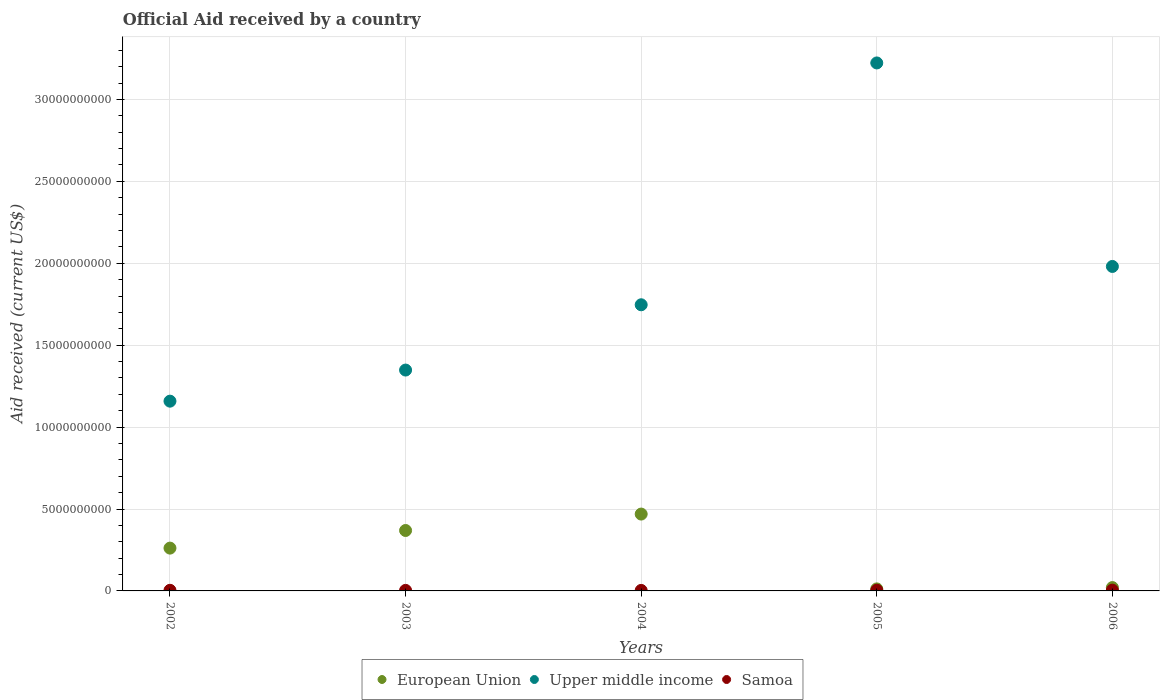How many different coloured dotlines are there?
Your answer should be very brief. 3. What is the net official aid received in Samoa in 2004?
Offer a very short reply. 3.09e+07. Across all years, what is the maximum net official aid received in Upper middle income?
Your response must be concise. 3.22e+1. Across all years, what is the minimum net official aid received in European Union?
Make the answer very short. 1.23e+08. In which year was the net official aid received in European Union maximum?
Ensure brevity in your answer.  2004. In which year was the net official aid received in Samoa minimum?
Your answer should be compact. 2004. What is the total net official aid received in Samoa in the graph?
Ensure brevity in your answer.  1.92e+08. What is the difference between the net official aid received in Samoa in 2004 and that in 2006?
Keep it short and to the point. -1.61e+07. What is the difference between the net official aid received in European Union in 2004 and the net official aid received in Samoa in 2003?
Provide a short and direct response. 4.66e+09. What is the average net official aid received in Samoa per year?
Your answer should be compact. 3.85e+07. In the year 2003, what is the difference between the net official aid received in Samoa and net official aid received in Upper middle income?
Make the answer very short. -1.34e+1. In how many years, is the net official aid received in Samoa greater than 4000000000 US$?
Provide a short and direct response. 0. What is the ratio of the net official aid received in European Union in 2002 to that in 2006?
Keep it short and to the point. 12.82. What is the difference between the highest and the second highest net official aid received in Samoa?
Offer a very short reply. 3.52e+06. What is the difference between the highest and the lowest net official aid received in Upper middle income?
Keep it short and to the point. 2.06e+1. Is the sum of the net official aid received in Upper middle income in 2002 and 2004 greater than the maximum net official aid received in Samoa across all years?
Provide a short and direct response. Yes. How many dotlines are there?
Your answer should be compact. 3. How many years are there in the graph?
Give a very brief answer. 5. What is the difference between two consecutive major ticks on the Y-axis?
Make the answer very short. 5.00e+09. Does the graph contain any zero values?
Keep it short and to the point. No. Does the graph contain grids?
Make the answer very short. Yes. Where does the legend appear in the graph?
Your response must be concise. Bottom center. What is the title of the graph?
Your response must be concise. Official Aid received by a country. What is the label or title of the X-axis?
Your answer should be very brief. Years. What is the label or title of the Y-axis?
Ensure brevity in your answer.  Aid received (current US$). What is the Aid received (current US$) in European Union in 2002?
Your answer should be compact. 2.61e+09. What is the Aid received (current US$) in Upper middle income in 2002?
Your answer should be very brief. 1.16e+1. What is the Aid received (current US$) of Samoa in 2002?
Offer a very short reply. 3.79e+07. What is the Aid received (current US$) in European Union in 2003?
Give a very brief answer. 3.69e+09. What is the Aid received (current US$) of Upper middle income in 2003?
Keep it short and to the point. 1.35e+1. What is the Aid received (current US$) of Samoa in 2003?
Give a very brief answer. 3.30e+07. What is the Aid received (current US$) in European Union in 2004?
Offer a terse response. 4.69e+09. What is the Aid received (current US$) of Upper middle income in 2004?
Offer a terse response. 1.75e+1. What is the Aid received (current US$) in Samoa in 2004?
Give a very brief answer. 3.09e+07. What is the Aid received (current US$) in European Union in 2005?
Provide a short and direct response. 1.23e+08. What is the Aid received (current US$) of Upper middle income in 2005?
Offer a very short reply. 3.22e+1. What is the Aid received (current US$) of Samoa in 2005?
Offer a very short reply. 4.36e+07. What is the Aid received (current US$) in European Union in 2006?
Your answer should be very brief. 2.04e+08. What is the Aid received (current US$) of Upper middle income in 2006?
Provide a succinct answer. 1.98e+1. What is the Aid received (current US$) in Samoa in 2006?
Your answer should be very brief. 4.71e+07. Across all years, what is the maximum Aid received (current US$) of European Union?
Your answer should be compact. 4.69e+09. Across all years, what is the maximum Aid received (current US$) in Upper middle income?
Your answer should be compact. 3.22e+1. Across all years, what is the maximum Aid received (current US$) in Samoa?
Keep it short and to the point. 4.71e+07. Across all years, what is the minimum Aid received (current US$) in European Union?
Keep it short and to the point. 1.23e+08. Across all years, what is the minimum Aid received (current US$) in Upper middle income?
Provide a succinct answer. 1.16e+1. Across all years, what is the minimum Aid received (current US$) of Samoa?
Ensure brevity in your answer.  3.09e+07. What is the total Aid received (current US$) in European Union in the graph?
Your answer should be very brief. 1.13e+1. What is the total Aid received (current US$) of Upper middle income in the graph?
Keep it short and to the point. 9.46e+1. What is the total Aid received (current US$) in Samoa in the graph?
Your response must be concise. 1.92e+08. What is the difference between the Aid received (current US$) in European Union in 2002 and that in 2003?
Give a very brief answer. -1.08e+09. What is the difference between the Aid received (current US$) in Upper middle income in 2002 and that in 2003?
Give a very brief answer. -1.90e+09. What is the difference between the Aid received (current US$) of Samoa in 2002 and that in 2003?
Provide a short and direct response. 4.90e+06. What is the difference between the Aid received (current US$) of European Union in 2002 and that in 2004?
Your answer should be compact. -2.08e+09. What is the difference between the Aid received (current US$) of Upper middle income in 2002 and that in 2004?
Your response must be concise. -5.88e+09. What is the difference between the Aid received (current US$) of Samoa in 2002 and that in 2004?
Give a very brief answer. 6.94e+06. What is the difference between the Aid received (current US$) in European Union in 2002 and that in 2005?
Offer a very short reply. 2.49e+09. What is the difference between the Aid received (current US$) of Upper middle income in 2002 and that in 2005?
Ensure brevity in your answer.  -2.06e+1. What is the difference between the Aid received (current US$) of Samoa in 2002 and that in 2005?
Provide a succinct answer. -5.68e+06. What is the difference between the Aid received (current US$) of European Union in 2002 and that in 2006?
Provide a short and direct response. 2.41e+09. What is the difference between the Aid received (current US$) of Upper middle income in 2002 and that in 2006?
Provide a short and direct response. -8.22e+09. What is the difference between the Aid received (current US$) in Samoa in 2002 and that in 2006?
Your answer should be very brief. -9.20e+06. What is the difference between the Aid received (current US$) in European Union in 2003 and that in 2004?
Provide a short and direct response. -1.00e+09. What is the difference between the Aid received (current US$) of Upper middle income in 2003 and that in 2004?
Offer a very short reply. -3.99e+09. What is the difference between the Aid received (current US$) in Samoa in 2003 and that in 2004?
Make the answer very short. 2.04e+06. What is the difference between the Aid received (current US$) of European Union in 2003 and that in 2005?
Offer a very short reply. 3.57e+09. What is the difference between the Aid received (current US$) in Upper middle income in 2003 and that in 2005?
Ensure brevity in your answer.  -1.87e+1. What is the difference between the Aid received (current US$) in Samoa in 2003 and that in 2005?
Make the answer very short. -1.06e+07. What is the difference between the Aid received (current US$) of European Union in 2003 and that in 2006?
Your answer should be very brief. 3.48e+09. What is the difference between the Aid received (current US$) of Upper middle income in 2003 and that in 2006?
Give a very brief answer. -6.32e+09. What is the difference between the Aid received (current US$) of Samoa in 2003 and that in 2006?
Offer a very short reply. -1.41e+07. What is the difference between the Aid received (current US$) of European Union in 2004 and that in 2005?
Give a very brief answer. 4.57e+09. What is the difference between the Aid received (current US$) in Upper middle income in 2004 and that in 2005?
Give a very brief answer. -1.48e+1. What is the difference between the Aid received (current US$) of Samoa in 2004 and that in 2005?
Offer a terse response. -1.26e+07. What is the difference between the Aid received (current US$) in European Union in 2004 and that in 2006?
Your response must be concise. 4.49e+09. What is the difference between the Aid received (current US$) of Upper middle income in 2004 and that in 2006?
Ensure brevity in your answer.  -2.34e+09. What is the difference between the Aid received (current US$) of Samoa in 2004 and that in 2006?
Offer a very short reply. -1.61e+07. What is the difference between the Aid received (current US$) of European Union in 2005 and that in 2006?
Provide a succinct answer. -8.04e+07. What is the difference between the Aid received (current US$) of Upper middle income in 2005 and that in 2006?
Provide a short and direct response. 1.24e+1. What is the difference between the Aid received (current US$) of Samoa in 2005 and that in 2006?
Offer a very short reply. -3.52e+06. What is the difference between the Aid received (current US$) in European Union in 2002 and the Aid received (current US$) in Upper middle income in 2003?
Give a very brief answer. -1.09e+1. What is the difference between the Aid received (current US$) in European Union in 2002 and the Aid received (current US$) in Samoa in 2003?
Your answer should be very brief. 2.58e+09. What is the difference between the Aid received (current US$) of Upper middle income in 2002 and the Aid received (current US$) of Samoa in 2003?
Your answer should be compact. 1.16e+1. What is the difference between the Aid received (current US$) in European Union in 2002 and the Aid received (current US$) in Upper middle income in 2004?
Your answer should be compact. -1.49e+1. What is the difference between the Aid received (current US$) in European Union in 2002 and the Aid received (current US$) in Samoa in 2004?
Offer a terse response. 2.58e+09. What is the difference between the Aid received (current US$) of Upper middle income in 2002 and the Aid received (current US$) of Samoa in 2004?
Give a very brief answer. 1.16e+1. What is the difference between the Aid received (current US$) of European Union in 2002 and the Aid received (current US$) of Upper middle income in 2005?
Make the answer very short. -2.96e+1. What is the difference between the Aid received (current US$) of European Union in 2002 and the Aid received (current US$) of Samoa in 2005?
Make the answer very short. 2.57e+09. What is the difference between the Aid received (current US$) in Upper middle income in 2002 and the Aid received (current US$) in Samoa in 2005?
Make the answer very short. 1.15e+1. What is the difference between the Aid received (current US$) of European Union in 2002 and the Aid received (current US$) of Upper middle income in 2006?
Keep it short and to the point. -1.72e+1. What is the difference between the Aid received (current US$) of European Union in 2002 and the Aid received (current US$) of Samoa in 2006?
Make the answer very short. 2.57e+09. What is the difference between the Aid received (current US$) of Upper middle income in 2002 and the Aid received (current US$) of Samoa in 2006?
Ensure brevity in your answer.  1.15e+1. What is the difference between the Aid received (current US$) in European Union in 2003 and the Aid received (current US$) in Upper middle income in 2004?
Ensure brevity in your answer.  -1.38e+1. What is the difference between the Aid received (current US$) of European Union in 2003 and the Aid received (current US$) of Samoa in 2004?
Your response must be concise. 3.66e+09. What is the difference between the Aid received (current US$) in Upper middle income in 2003 and the Aid received (current US$) in Samoa in 2004?
Make the answer very short. 1.35e+1. What is the difference between the Aid received (current US$) of European Union in 2003 and the Aid received (current US$) of Upper middle income in 2005?
Offer a very short reply. -2.85e+1. What is the difference between the Aid received (current US$) in European Union in 2003 and the Aid received (current US$) in Samoa in 2005?
Offer a terse response. 3.65e+09. What is the difference between the Aid received (current US$) in Upper middle income in 2003 and the Aid received (current US$) in Samoa in 2005?
Provide a succinct answer. 1.34e+1. What is the difference between the Aid received (current US$) of European Union in 2003 and the Aid received (current US$) of Upper middle income in 2006?
Your response must be concise. -1.61e+1. What is the difference between the Aid received (current US$) of European Union in 2003 and the Aid received (current US$) of Samoa in 2006?
Ensure brevity in your answer.  3.64e+09. What is the difference between the Aid received (current US$) of Upper middle income in 2003 and the Aid received (current US$) of Samoa in 2006?
Make the answer very short. 1.34e+1. What is the difference between the Aid received (current US$) in European Union in 2004 and the Aid received (current US$) in Upper middle income in 2005?
Give a very brief answer. -2.75e+1. What is the difference between the Aid received (current US$) in European Union in 2004 and the Aid received (current US$) in Samoa in 2005?
Provide a succinct answer. 4.65e+09. What is the difference between the Aid received (current US$) of Upper middle income in 2004 and the Aid received (current US$) of Samoa in 2005?
Provide a short and direct response. 1.74e+1. What is the difference between the Aid received (current US$) of European Union in 2004 and the Aid received (current US$) of Upper middle income in 2006?
Make the answer very short. -1.51e+1. What is the difference between the Aid received (current US$) in European Union in 2004 and the Aid received (current US$) in Samoa in 2006?
Your response must be concise. 4.64e+09. What is the difference between the Aid received (current US$) in Upper middle income in 2004 and the Aid received (current US$) in Samoa in 2006?
Offer a very short reply. 1.74e+1. What is the difference between the Aid received (current US$) of European Union in 2005 and the Aid received (current US$) of Upper middle income in 2006?
Offer a terse response. -1.97e+1. What is the difference between the Aid received (current US$) of European Union in 2005 and the Aid received (current US$) of Samoa in 2006?
Your answer should be compact. 7.64e+07. What is the difference between the Aid received (current US$) in Upper middle income in 2005 and the Aid received (current US$) in Samoa in 2006?
Offer a very short reply. 3.22e+1. What is the average Aid received (current US$) of European Union per year?
Offer a very short reply. 2.26e+09. What is the average Aid received (current US$) in Upper middle income per year?
Provide a succinct answer. 1.89e+1. What is the average Aid received (current US$) in Samoa per year?
Provide a succinct answer. 3.85e+07. In the year 2002, what is the difference between the Aid received (current US$) in European Union and Aid received (current US$) in Upper middle income?
Offer a terse response. -8.97e+09. In the year 2002, what is the difference between the Aid received (current US$) of European Union and Aid received (current US$) of Samoa?
Give a very brief answer. 2.58e+09. In the year 2002, what is the difference between the Aid received (current US$) of Upper middle income and Aid received (current US$) of Samoa?
Your answer should be compact. 1.15e+1. In the year 2003, what is the difference between the Aid received (current US$) of European Union and Aid received (current US$) of Upper middle income?
Your answer should be compact. -9.79e+09. In the year 2003, what is the difference between the Aid received (current US$) of European Union and Aid received (current US$) of Samoa?
Your answer should be very brief. 3.66e+09. In the year 2003, what is the difference between the Aid received (current US$) of Upper middle income and Aid received (current US$) of Samoa?
Provide a succinct answer. 1.34e+1. In the year 2004, what is the difference between the Aid received (current US$) in European Union and Aid received (current US$) in Upper middle income?
Your answer should be compact. -1.28e+1. In the year 2004, what is the difference between the Aid received (current US$) of European Union and Aid received (current US$) of Samoa?
Provide a short and direct response. 4.66e+09. In the year 2004, what is the difference between the Aid received (current US$) of Upper middle income and Aid received (current US$) of Samoa?
Your answer should be very brief. 1.74e+1. In the year 2005, what is the difference between the Aid received (current US$) in European Union and Aid received (current US$) in Upper middle income?
Give a very brief answer. -3.21e+1. In the year 2005, what is the difference between the Aid received (current US$) of European Union and Aid received (current US$) of Samoa?
Your answer should be compact. 7.99e+07. In the year 2005, what is the difference between the Aid received (current US$) of Upper middle income and Aid received (current US$) of Samoa?
Keep it short and to the point. 3.22e+1. In the year 2006, what is the difference between the Aid received (current US$) of European Union and Aid received (current US$) of Upper middle income?
Keep it short and to the point. -1.96e+1. In the year 2006, what is the difference between the Aid received (current US$) of European Union and Aid received (current US$) of Samoa?
Offer a terse response. 1.57e+08. In the year 2006, what is the difference between the Aid received (current US$) in Upper middle income and Aid received (current US$) in Samoa?
Offer a very short reply. 1.98e+1. What is the ratio of the Aid received (current US$) of European Union in 2002 to that in 2003?
Ensure brevity in your answer.  0.71. What is the ratio of the Aid received (current US$) of Upper middle income in 2002 to that in 2003?
Make the answer very short. 0.86. What is the ratio of the Aid received (current US$) of Samoa in 2002 to that in 2003?
Provide a short and direct response. 1.15. What is the ratio of the Aid received (current US$) of European Union in 2002 to that in 2004?
Give a very brief answer. 0.56. What is the ratio of the Aid received (current US$) of Upper middle income in 2002 to that in 2004?
Offer a very short reply. 0.66. What is the ratio of the Aid received (current US$) of Samoa in 2002 to that in 2004?
Keep it short and to the point. 1.22. What is the ratio of the Aid received (current US$) in European Union in 2002 to that in 2005?
Your response must be concise. 21.16. What is the ratio of the Aid received (current US$) in Upper middle income in 2002 to that in 2005?
Provide a succinct answer. 0.36. What is the ratio of the Aid received (current US$) of Samoa in 2002 to that in 2005?
Make the answer very short. 0.87. What is the ratio of the Aid received (current US$) in European Union in 2002 to that in 2006?
Your response must be concise. 12.82. What is the ratio of the Aid received (current US$) in Upper middle income in 2002 to that in 2006?
Make the answer very short. 0.58. What is the ratio of the Aid received (current US$) in Samoa in 2002 to that in 2006?
Offer a very short reply. 0.8. What is the ratio of the Aid received (current US$) of European Union in 2003 to that in 2004?
Make the answer very short. 0.79. What is the ratio of the Aid received (current US$) in Upper middle income in 2003 to that in 2004?
Your answer should be compact. 0.77. What is the ratio of the Aid received (current US$) in Samoa in 2003 to that in 2004?
Offer a very short reply. 1.07. What is the ratio of the Aid received (current US$) in European Union in 2003 to that in 2005?
Provide a short and direct response. 29.88. What is the ratio of the Aid received (current US$) in Upper middle income in 2003 to that in 2005?
Give a very brief answer. 0.42. What is the ratio of the Aid received (current US$) of Samoa in 2003 to that in 2005?
Give a very brief answer. 0.76. What is the ratio of the Aid received (current US$) in European Union in 2003 to that in 2006?
Ensure brevity in your answer.  18.1. What is the ratio of the Aid received (current US$) in Upper middle income in 2003 to that in 2006?
Provide a succinct answer. 0.68. What is the ratio of the Aid received (current US$) in Samoa in 2003 to that in 2006?
Your response must be concise. 0.7. What is the ratio of the Aid received (current US$) in European Union in 2004 to that in 2005?
Provide a short and direct response. 38. What is the ratio of the Aid received (current US$) of Upper middle income in 2004 to that in 2005?
Your answer should be compact. 0.54. What is the ratio of the Aid received (current US$) of Samoa in 2004 to that in 2005?
Make the answer very short. 0.71. What is the ratio of the Aid received (current US$) in European Union in 2004 to that in 2006?
Ensure brevity in your answer.  23.02. What is the ratio of the Aid received (current US$) in Upper middle income in 2004 to that in 2006?
Offer a very short reply. 0.88. What is the ratio of the Aid received (current US$) of Samoa in 2004 to that in 2006?
Provide a short and direct response. 0.66. What is the ratio of the Aid received (current US$) in European Union in 2005 to that in 2006?
Your answer should be compact. 0.61. What is the ratio of the Aid received (current US$) of Upper middle income in 2005 to that in 2006?
Provide a short and direct response. 1.63. What is the ratio of the Aid received (current US$) of Samoa in 2005 to that in 2006?
Offer a very short reply. 0.93. What is the difference between the highest and the second highest Aid received (current US$) of European Union?
Your answer should be compact. 1.00e+09. What is the difference between the highest and the second highest Aid received (current US$) of Upper middle income?
Offer a terse response. 1.24e+1. What is the difference between the highest and the second highest Aid received (current US$) in Samoa?
Ensure brevity in your answer.  3.52e+06. What is the difference between the highest and the lowest Aid received (current US$) of European Union?
Make the answer very short. 4.57e+09. What is the difference between the highest and the lowest Aid received (current US$) in Upper middle income?
Your answer should be compact. 2.06e+1. What is the difference between the highest and the lowest Aid received (current US$) of Samoa?
Provide a short and direct response. 1.61e+07. 